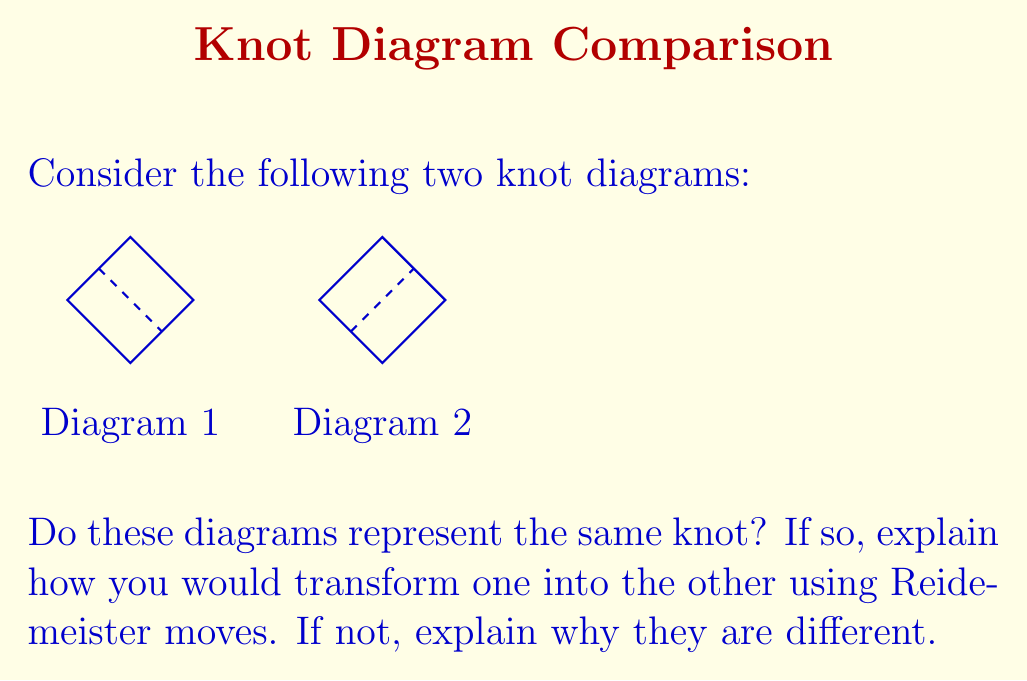Can you solve this math problem? To determine if these knot diagrams represent the same knot, we need to analyze if we can transform one into the other using Reidemeister moves. Let's approach this step-by-step:

1. First, let's identify the key features of each diagram:
   - Both diagrams show a single closed loop with one crossing.
   - The difference is in the type of crossing: Diagram 1 has an overpass, while Diagram 2 has an underpass.

2. Recall the three types of Reidemeister moves:
   - Type I: Adding or removing a twist in the knot
   - Type II: Moving one strand completely over or under another
   - Type III: Moving a strand over or under a crossing

3. In this case, we can transform Diagram 1 into Diagram 2 using a single Reidemeister move:
   - Apply a Type I move to Diagram 1 by twisting the overpass to create an underpass.

4. The process would look like this:
   a. Start with Diagram 1
   b. Imagine grabbing the overpass and twisting it 180 degrees
   c. This twist changes the overpass to an underpass, resulting in Diagram 2

5. Since we can transform one diagram into the other using a single Reidemeister move, we can conclude that these diagrams represent the same knot.

From a funding perspective, this demonstrates how a seemingly complex problem (identifying equivalent knots) can often be solved with a simple, elegant solution (a single Reidemeister move). This efficiency in problem-solving could be an attractive point when seeking funding for mathematical research.
Answer: Yes, they represent the same knot. Transformable by one Type I Reidemeister move. 